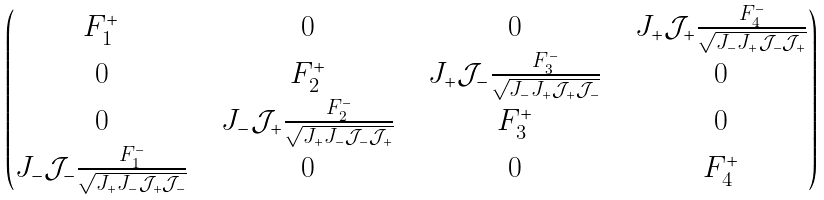<formula> <loc_0><loc_0><loc_500><loc_500>\begin{pmatrix} F _ { 1 } ^ { + } & & 0 & & 0 & & J _ { + } \mathcal { J } _ { + } \frac { F _ { 4 } ^ { - } } { \sqrt { J _ { - } J _ { + } \mathcal { J } _ { - } \mathcal { J } _ { + } } } \\ 0 & & F _ { 2 } ^ { + } & & J _ { + } \mathcal { J } _ { - } \frac { F _ { 3 } ^ { - } } { \sqrt { J _ { - } J _ { + } \mathcal { J } _ { + } \mathcal { J } _ { - } } } & & 0 \\ 0 & & J _ { - } \mathcal { J } _ { + } \frac { F _ { 2 } ^ { - } } { \sqrt { J _ { + } J _ { - } \mathcal { J } _ { - } \mathcal { J } _ { + } } } & & F _ { 3 } ^ { + } & & 0 \\ J _ { - } \mathcal { J } _ { - } \frac { F _ { 1 } ^ { - } } { \sqrt { J _ { + } J _ { - } \mathcal { J } _ { + } \mathcal { J } _ { - } } } & & 0 & & 0 & & F ^ { + } _ { 4 } \end{pmatrix}</formula> 